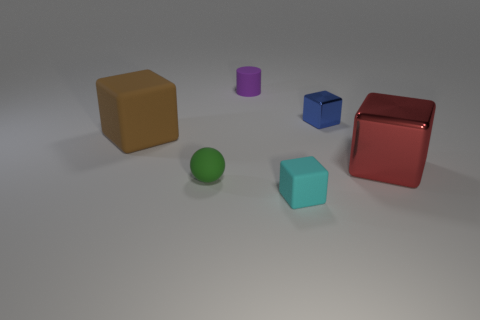There is a small rubber object that is behind the ball in front of the big metallic block; what shape is it?
Your answer should be compact. Cylinder. Are there any large cyan shiny things that have the same shape as the brown matte thing?
Make the answer very short. No. There is a sphere; is its color the same as the small cube behind the green rubber thing?
Provide a succinct answer. No. Is there a matte cube that has the same size as the green rubber thing?
Your response must be concise. Yes. Are the big brown object and the large thing to the right of the green object made of the same material?
Offer a very short reply. No. Is the number of blue things greater than the number of large blocks?
Keep it short and to the point. No. How many cubes are objects or tiny green objects?
Keep it short and to the point. 4. What color is the big matte block?
Offer a very short reply. Brown. There is a cube that is in front of the large red object; is its size the same as the rubber block behind the big metal object?
Your answer should be very brief. No. Is the number of small purple things less than the number of metal things?
Your answer should be compact. Yes. 